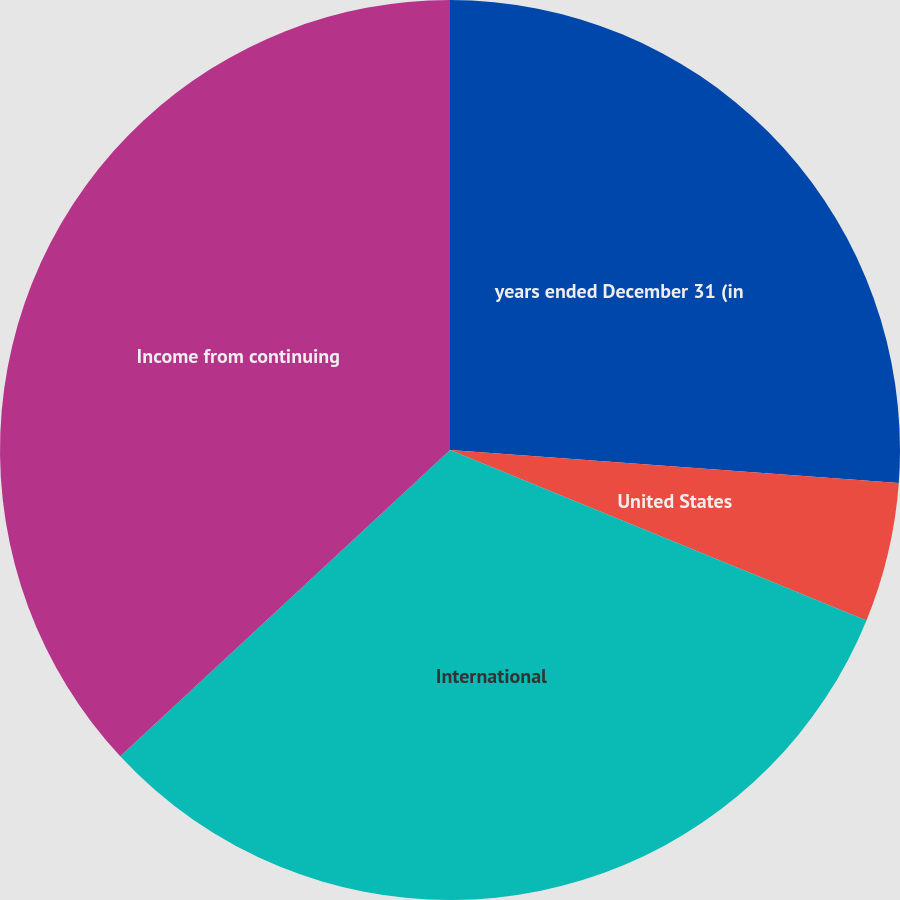Convert chart to OTSL. <chart><loc_0><loc_0><loc_500><loc_500><pie_chart><fcel>years ended December 31 (in<fcel>United States<fcel>International<fcel>Income from continuing<nl><fcel>26.17%<fcel>5.01%<fcel>31.91%<fcel>36.91%<nl></chart> 